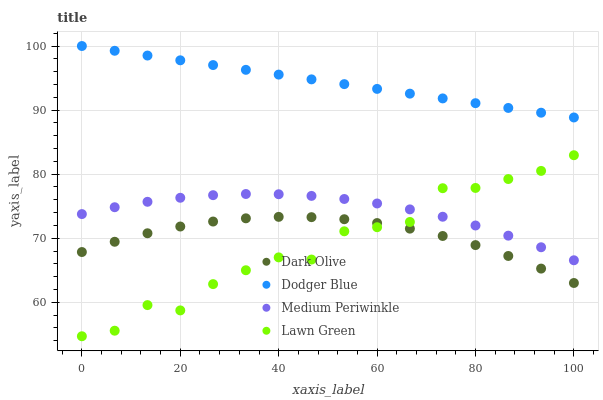Does Lawn Green have the minimum area under the curve?
Answer yes or no. Yes. Does Dodger Blue have the maximum area under the curve?
Answer yes or no. Yes. Does Dark Olive have the minimum area under the curve?
Answer yes or no. No. Does Dark Olive have the maximum area under the curve?
Answer yes or no. No. Is Dodger Blue the smoothest?
Answer yes or no. Yes. Is Lawn Green the roughest?
Answer yes or no. Yes. Is Dark Olive the smoothest?
Answer yes or no. No. Is Dark Olive the roughest?
Answer yes or no. No. Does Lawn Green have the lowest value?
Answer yes or no. Yes. Does Dark Olive have the lowest value?
Answer yes or no. No. Does Dodger Blue have the highest value?
Answer yes or no. Yes. Does Dark Olive have the highest value?
Answer yes or no. No. Is Dark Olive less than Medium Periwinkle?
Answer yes or no. Yes. Is Dodger Blue greater than Dark Olive?
Answer yes or no. Yes. Does Lawn Green intersect Dark Olive?
Answer yes or no. Yes. Is Lawn Green less than Dark Olive?
Answer yes or no. No. Is Lawn Green greater than Dark Olive?
Answer yes or no. No. Does Dark Olive intersect Medium Periwinkle?
Answer yes or no. No. 